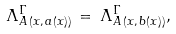<formula> <loc_0><loc_0><loc_500><loc_500>\Lambda _ { A \, ( x , \, a ( x ) ) } ^ { \Gamma } \, = \, \Lambda _ { A \, ( x , \, b ( x ) ) } ^ { \Gamma } ,</formula> 